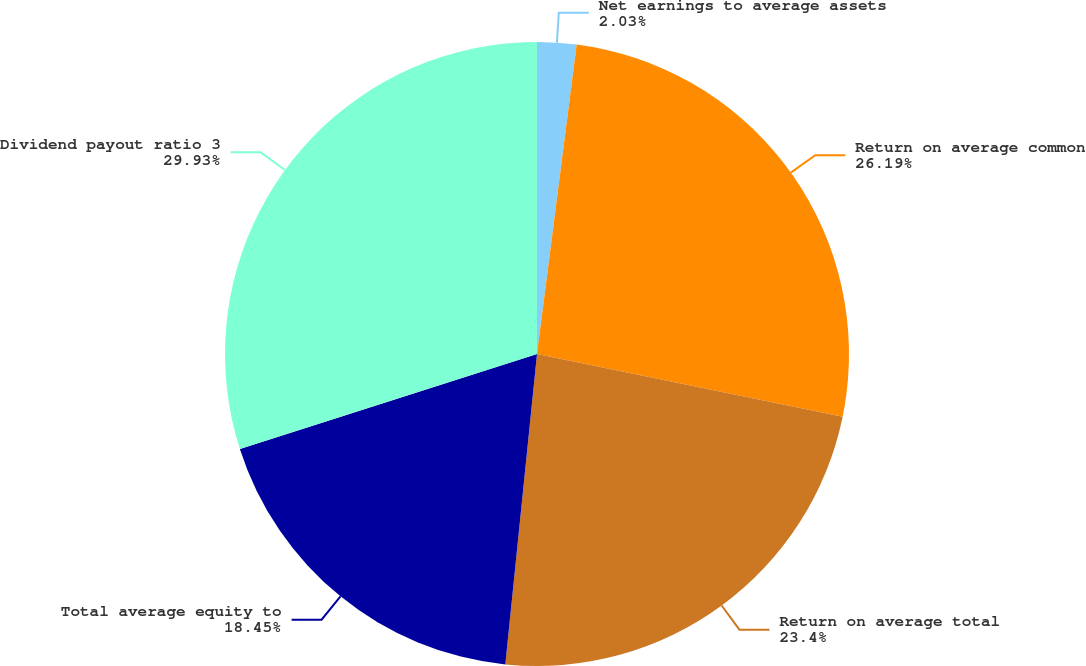Convert chart to OTSL. <chart><loc_0><loc_0><loc_500><loc_500><pie_chart><fcel>Net earnings to average assets<fcel>Return on average common<fcel>Return on average total<fcel>Total average equity to<fcel>Dividend payout ratio 3<nl><fcel>2.03%<fcel>26.19%<fcel>23.4%<fcel>18.45%<fcel>29.93%<nl></chart> 